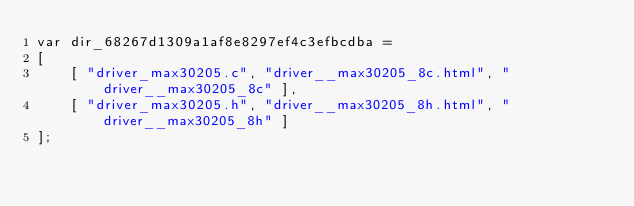<code> <loc_0><loc_0><loc_500><loc_500><_JavaScript_>var dir_68267d1309a1af8e8297ef4c3efbcdba =
[
    [ "driver_max30205.c", "driver__max30205_8c.html", "driver__max30205_8c" ],
    [ "driver_max30205.h", "driver__max30205_8h.html", "driver__max30205_8h" ]
];</code> 